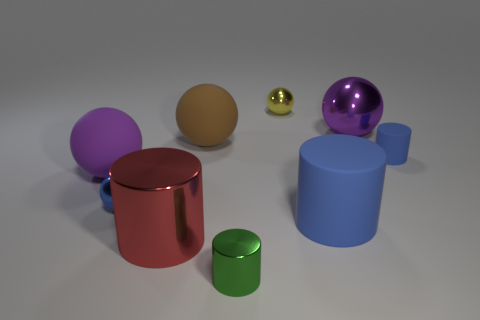What is the size of the brown thing?
Make the answer very short. Large. There is a metal sphere that is to the right of the rubber cylinder that is on the left side of the purple object that is to the right of the small green object; what size is it?
Make the answer very short. Large. How many other things are there of the same material as the yellow ball?
Your answer should be very brief. 4. What material is the blue cylinder behind the purple ball that is left of the large matte ball that is behind the large purple rubber sphere made of?
Ensure brevity in your answer.  Rubber. Is there a big rubber thing?
Give a very brief answer. Yes. There is a large shiny sphere; does it have the same color as the rubber sphere that is to the left of the brown matte ball?
Offer a very short reply. Yes. What color is the big metallic cylinder?
Provide a short and direct response. Red. Are there any other things that are the same shape as the green shiny thing?
Offer a very short reply. Yes. There is a tiny matte thing that is the same shape as the large red thing; what color is it?
Give a very brief answer. Blue. Do the small yellow metal thing and the big brown rubber thing have the same shape?
Give a very brief answer. Yes. 